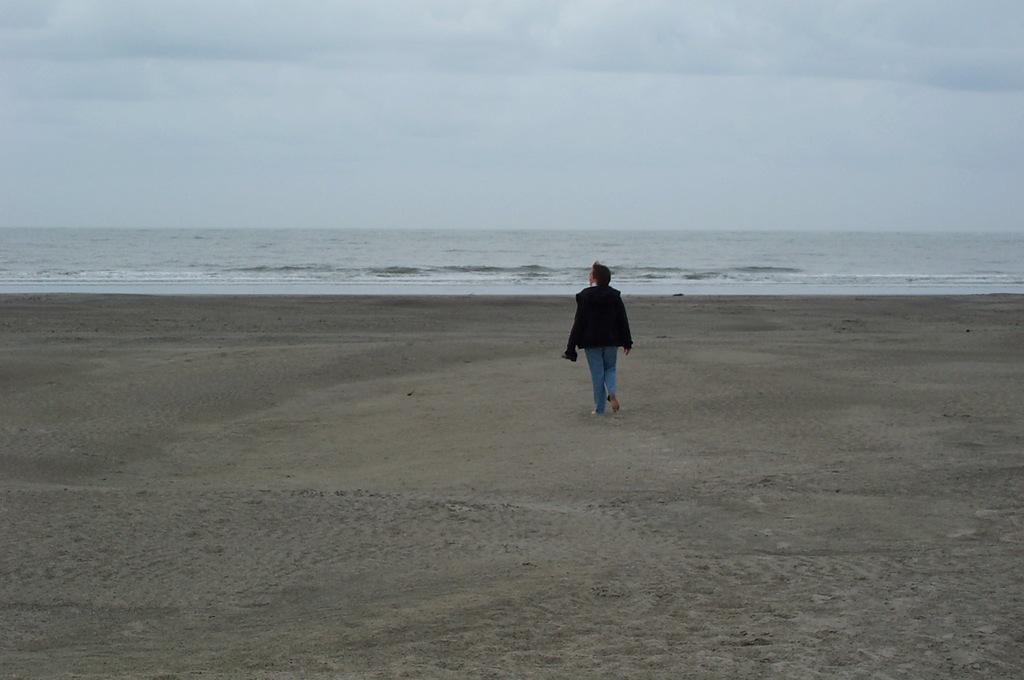Describe this image in one or two sentences. In this image a person is walking in the sea beach. In the background there is sea and sky. 